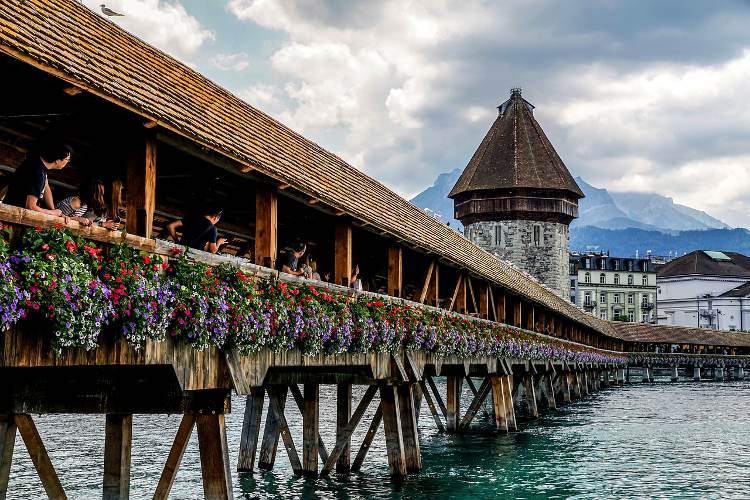Imagine if the bridge could talk. What stories would it tell? If the Chapel Bridge could talk, it would share stories of centuries past, beginning with its construction in 1333. It would recount its role in protecting the city as part of Lucerne's fortifications and the many feet that have walked its wooden planks over the centuries. The bridge would tell tales of traders and townsfolk crossing the river, the transformations it witnessed in the cityscape, and the resilience it showed after the tragic fire of 1993, which led to its restoration. It would share the quiet moments of dawn as the mist rose from the river and the bustling days of festivals when its structure was adorned with even more flowers and decorations. The bridge would speak of the enduring beauty of the Swiss Alps that have stood by it as silent spectators through wars, peace, and countless chapters of history. 